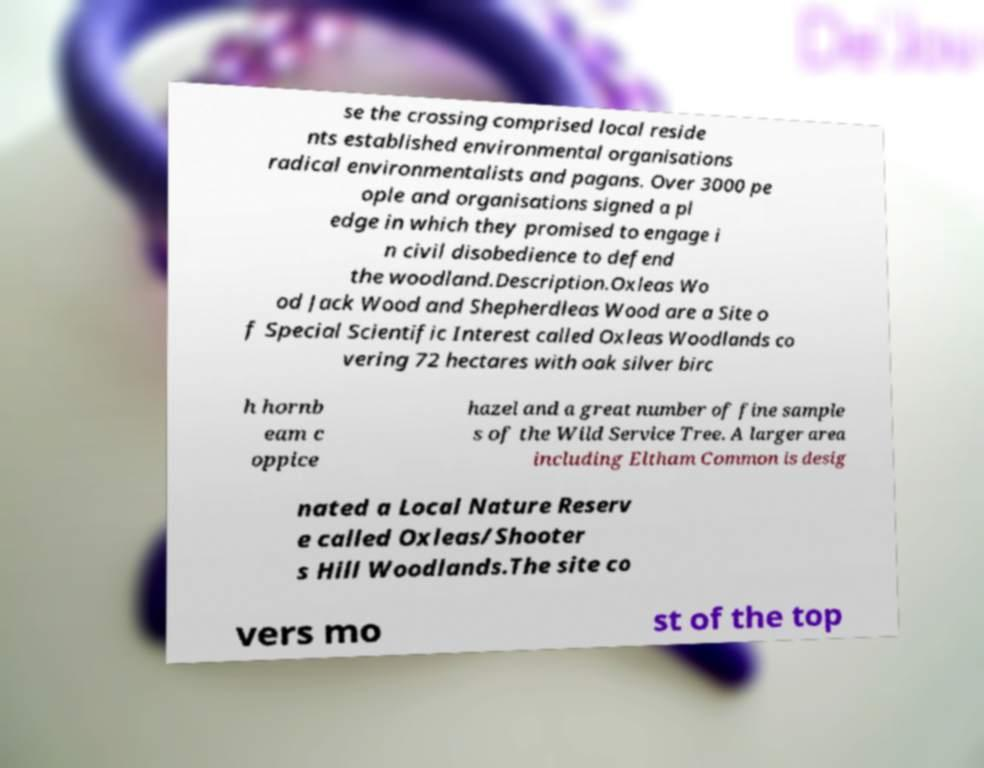Could you extract and type out the text from this image? se the crossing comprised local reside nts established environmental organisations radical environmentalists and pagans. Over 3000 pe ople and organisations signed a pl edge in which they promised to engage i n civil disobedience to defend the woodland.Description.Oxleas Wo od Jack Wood and Shepherdleas Wood are a Site o f Special Scientific Interest called Oxleas Woodlands co vering 72 hectares with oak silver birc h hornb eam c oppice hazel and a great number of fine sample s of the Wild Service Tree. A larger area including Eltham Common is desig nated a Local Nature Reserv e called Oxleas/Shooter s Hill Woodlands.The site co vers mo st of the top 